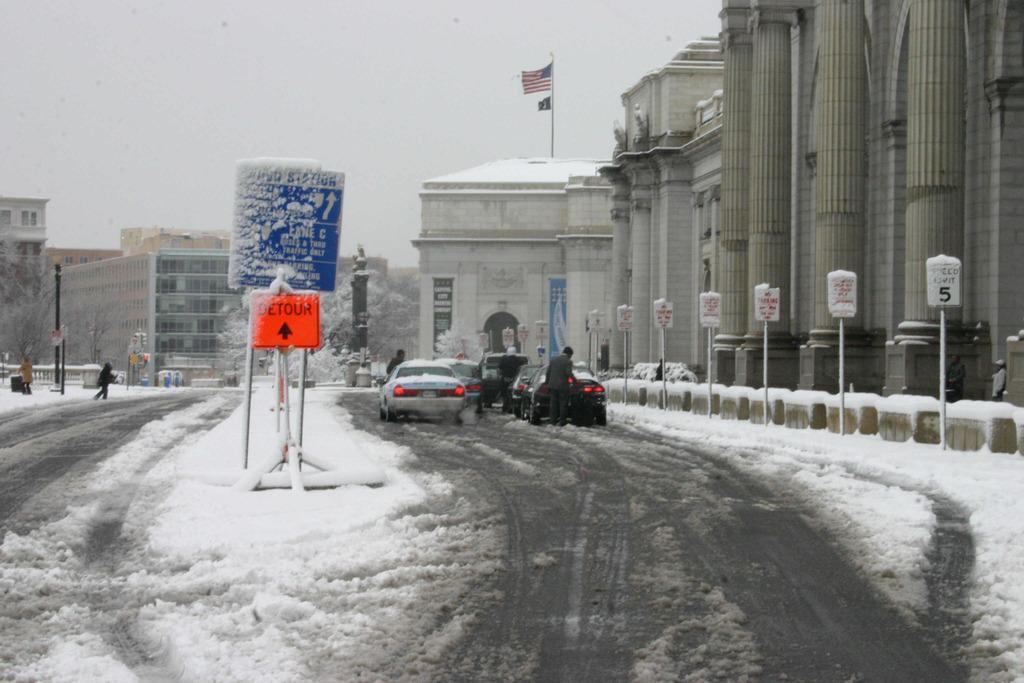Can you describe this image briefly? In this image, we can see some buildings. There are cars on the road. There are pillars in the top right of the image. There are poles on the right side of the image. There are boards in the middle of the image. There is a sky at the top of the image. 